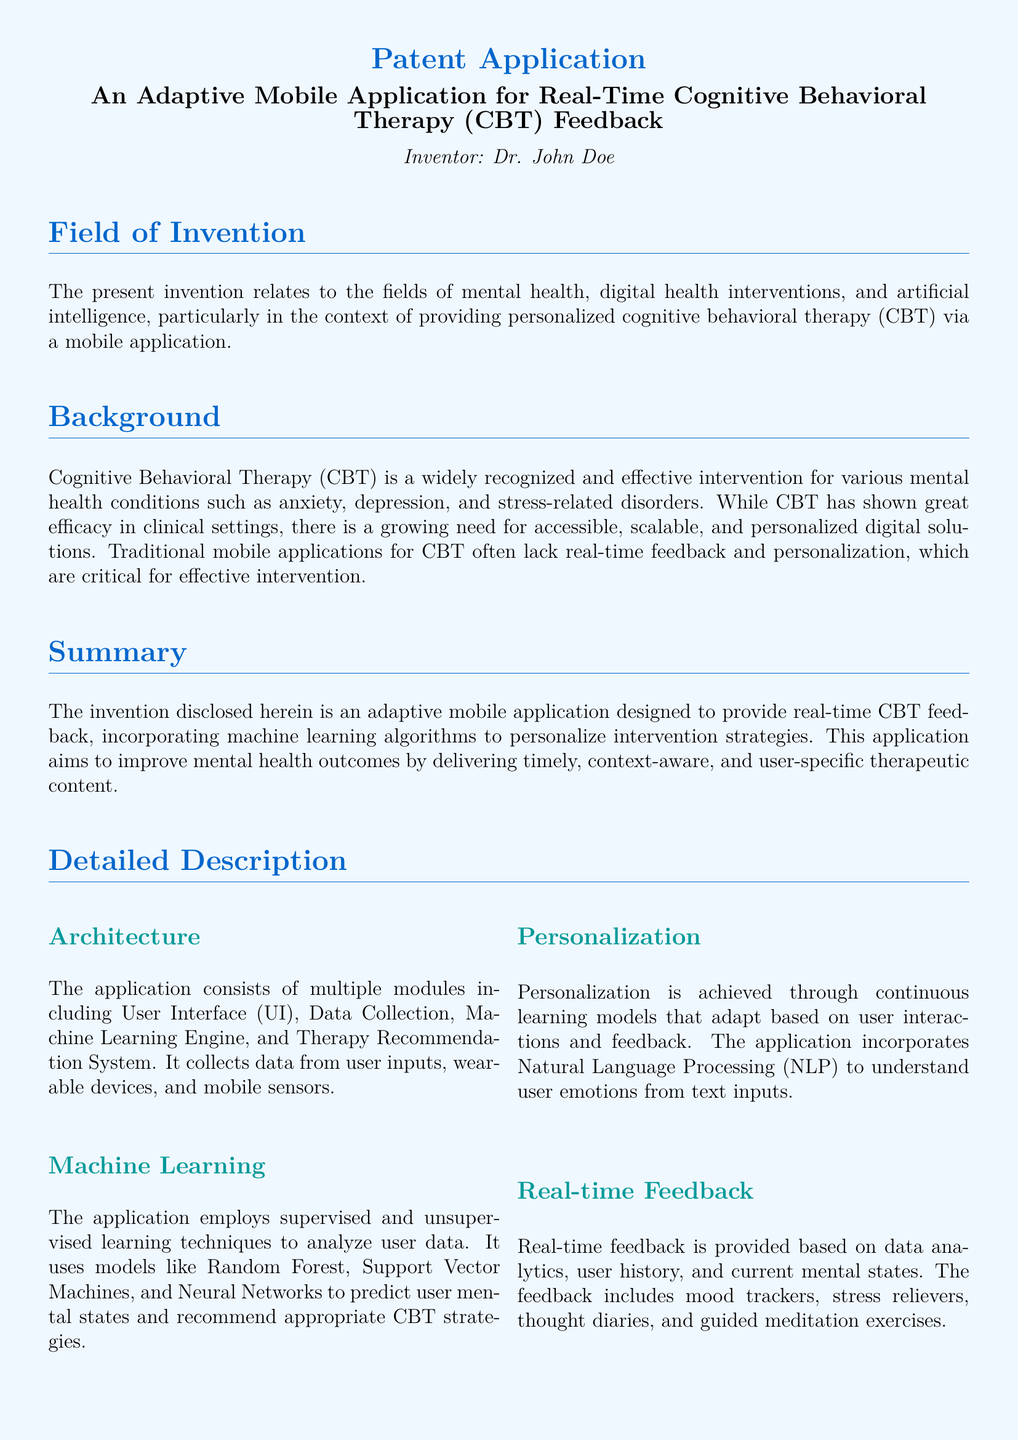What is the title of the invention? The title of the invention is stated at the top of the document as "An Adaptive Mobile Application for Real-Time Cognitive Behavioral Therapy (CBT) Feedback."
Answer: An Adaptive Mobile Application for Real-Time Cognitive Behavioral Therapy (CBT) Feedback Who is the inventor? The inventor is mentioned in the center of the document, which states "Inventor: Dr. John Doe."
Answer: Dr. John Doe What is the primary field of the invention? The primary field of the invention is mentioned in the "Field of Invention" section, stating it relates to mental health and digital health interventions.
Answer: Mental health, digital health interventions How does the application provide feedback? The document describes that the application provides feedback through "real-time" mechanisms based on data analytics and user history.
Answer: Real-time What techniques does the machine learning engine use? The document specifies that the machine learning engine uses "supervised and unsupervised learning techniques" to tailor interventions.
Answer: Supervised and unsupervised learning techniques What types of data does the application collect? The application collects data from "user inputs, wearable devices, and mobile sensors" as outlined in the architecture section.
Answer: User inputs, wearable devices, mobile sensors What does NLP stand for in this context? The term NLP is referenced in the section regarding personalization, indicating it stands for "Natural Language Processing."
Answer: Natural Language Processing What is one use case for the application? One use case is described in the document where a user feels anxious during a meeting, and the application suggests a guided breathing exercise.
Answer: A user feels anxious during a meeting How is user data treated regarding privacy? The application maintains user privacy by ensuring that user data is "anonymized and encrypted" as mentioned in the security and privacy section.
Answer: Anonymized and encrypted How are the claims structured in this patent application? The claims are structured as numbered points that specify the features of the adaptive mobile application, highlighting different aspects of the invention.
Answer: Numbered points 